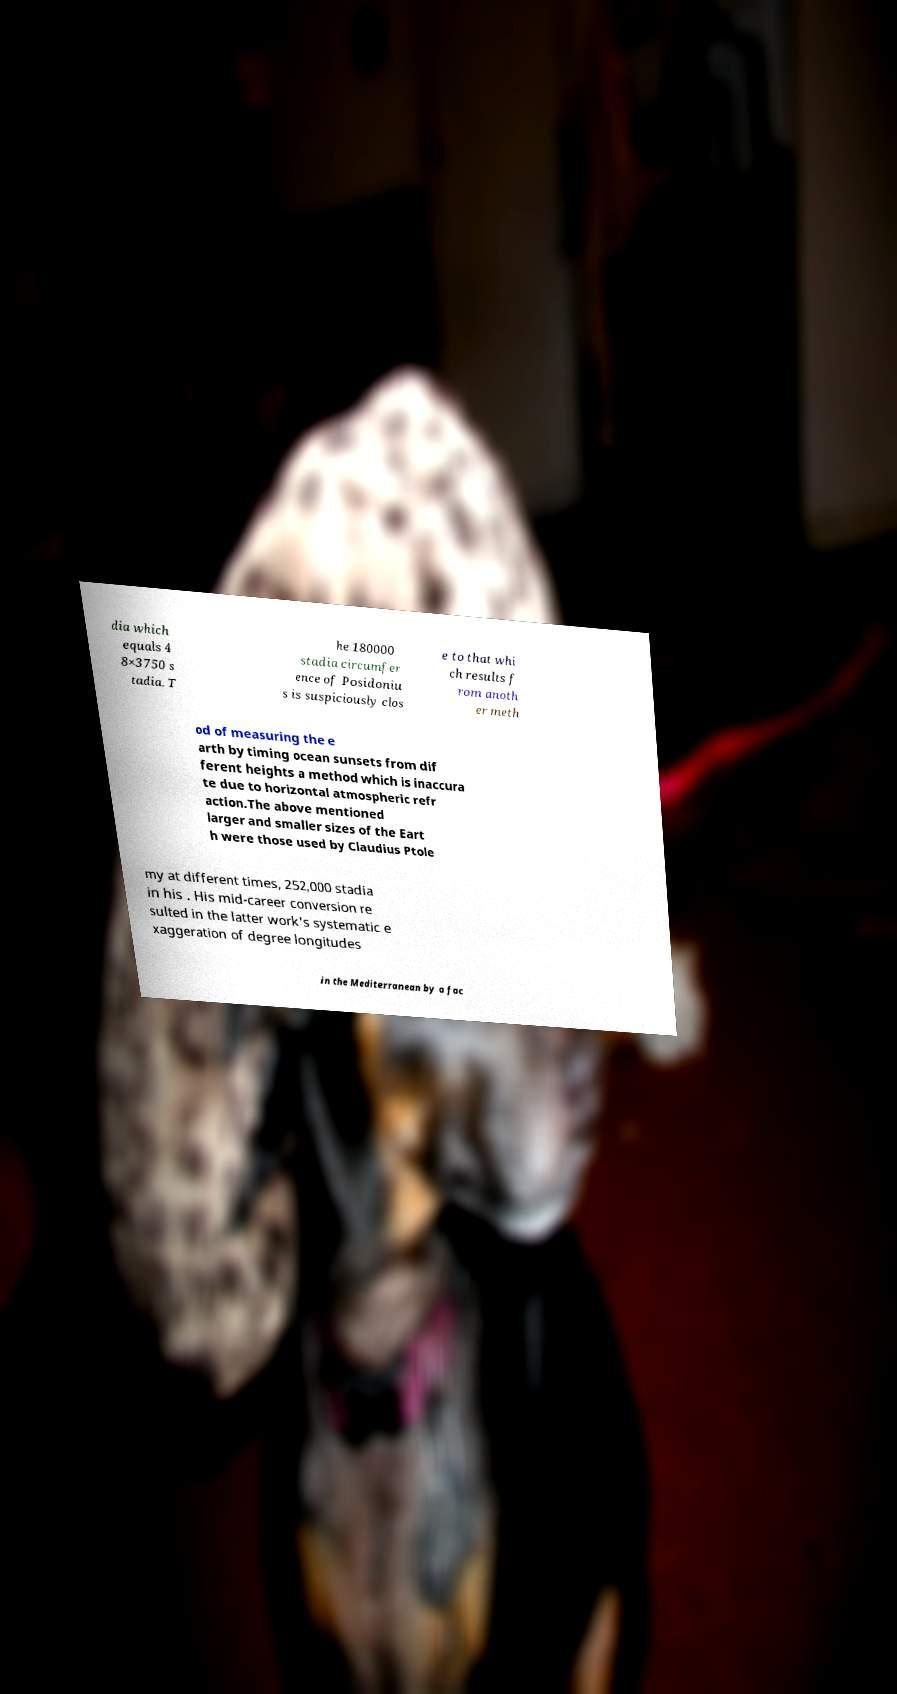There's text embedded in this image that I need extracted. Can you transcribe it verbatim? dia which equals 4 8×3750 s tadia. T he 180000 stadia circumfer ence of Posidoniu s is suspiciously clos e to that whi ch results f rom anoth er meth od of measuring the e arth by timing ocean sunsets from dif ferent heights a method which is inaccura te due to horizontal atmospheric refr action.The above mentioned larger and smaller sizes of the Eart h were those used by Claudius Ptole my at different times, 252,000 stadia in his . His mid-career conversion re sulted in the latter work's systematic e xaggeration of degree longitudes in the Mediterranean by a fac 